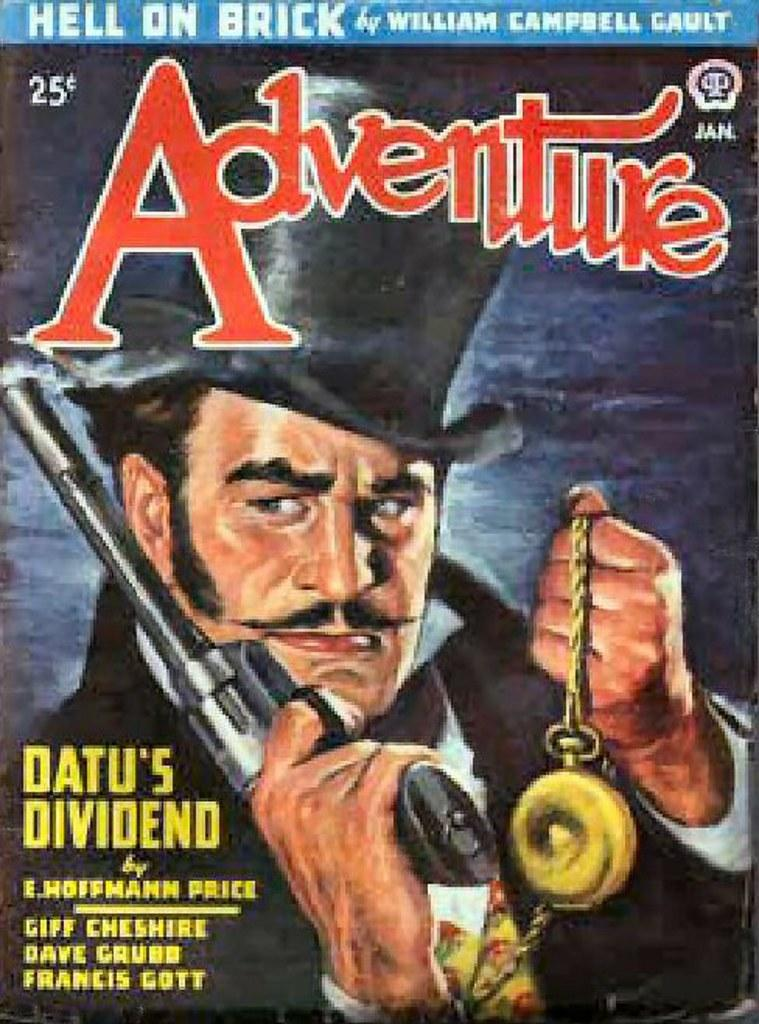What is featured in the image in the form of a printed material? There is a poster in the image. What is depicted in the image on the poster? The poster contains an image of a man holding a gun and an object. Is there any text present on the poster? Yes, there is text present on the poster. Where is the playground located in the image? There is no playground present in the image; it features a poster with an image of a man holding a gun and an object. What type of pen is being used by the man in the image? There is no pen visible in the image; the man is holding a gun and an object. 